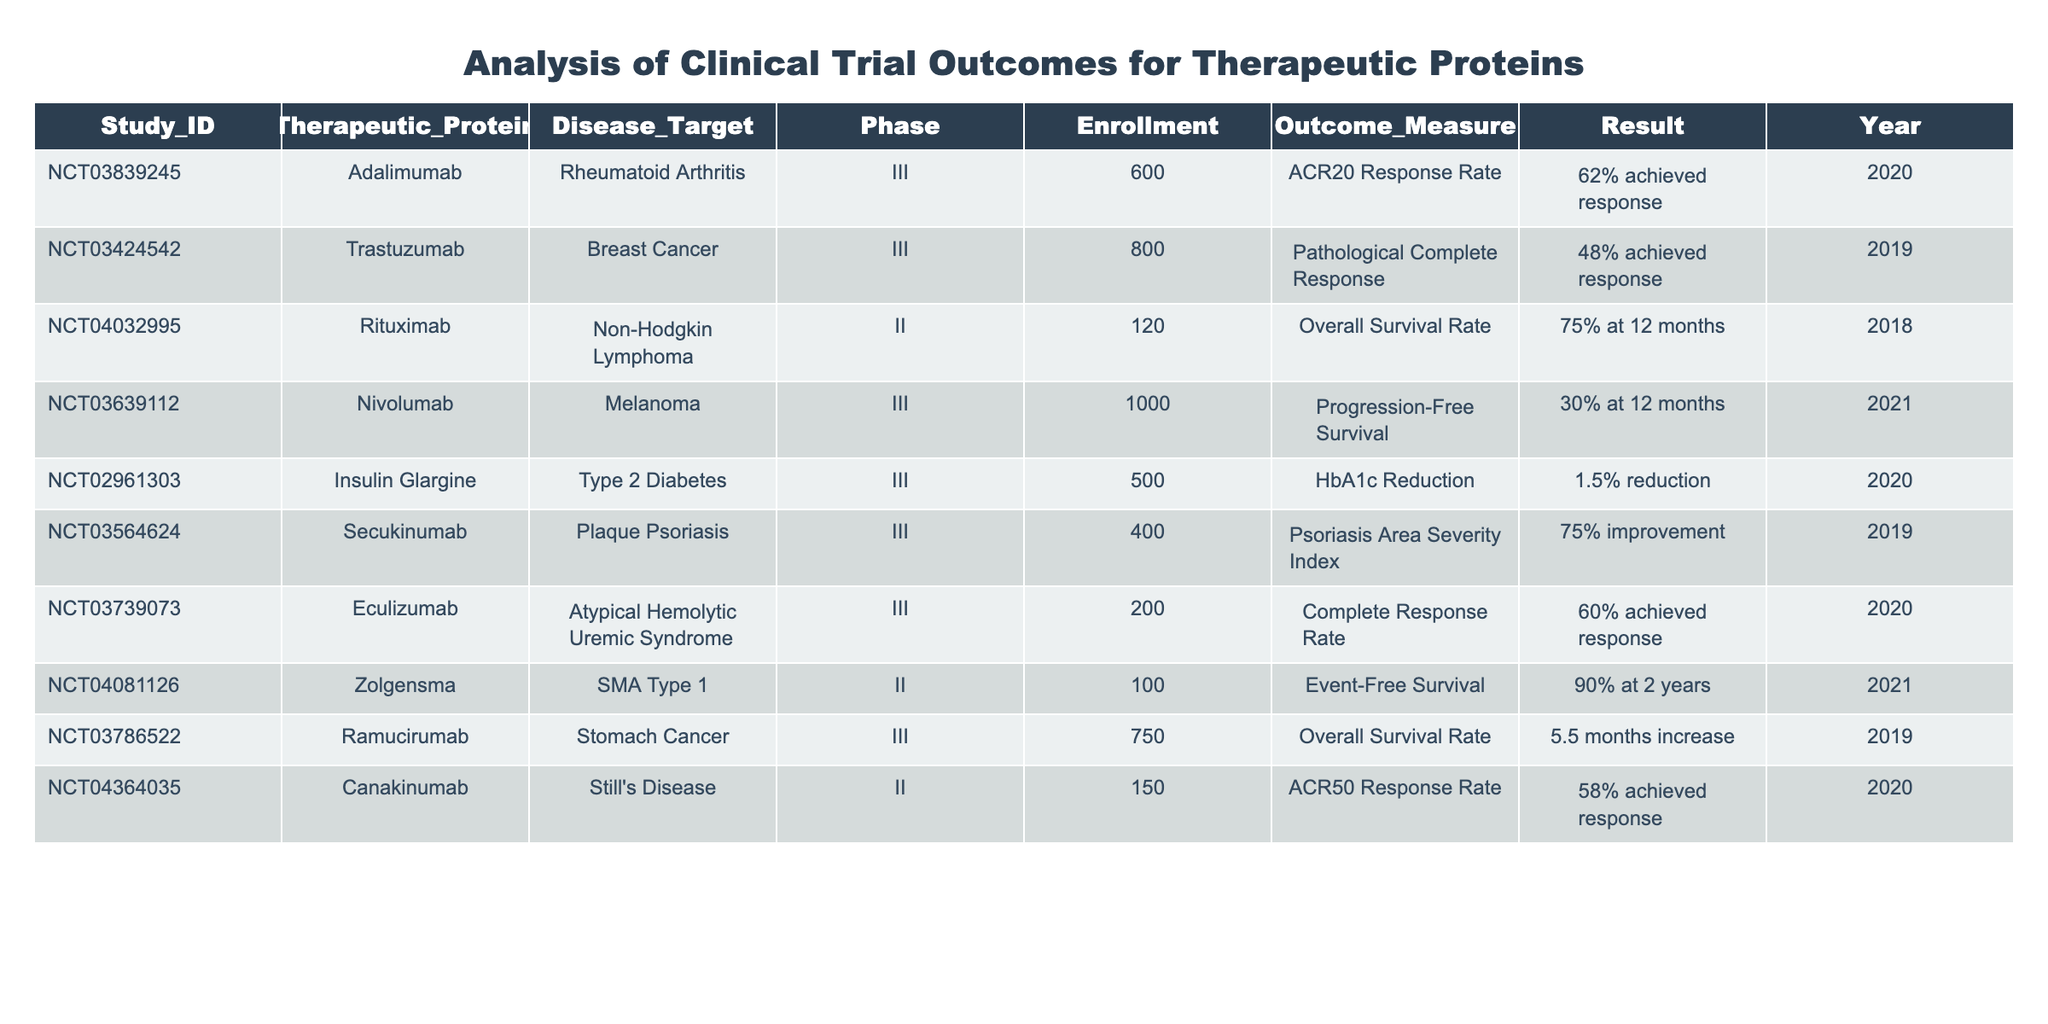What is the enrollment for the study evaluating Zolgensma? The table shows that the enrollment for the study identified by study ID NCT04081126, which evaluates Zolgensma for SMA Type 1, is 100.
Answer: 100 What percentage of participants achieved the ACR20 response rate with Adalimumab? The table indicates that for the study NCT03839245 examining Adalimumab for rheumatoid arthritis, 62% of participants achieved the ACR20 response rate.
Answer: 62% Which therapeutic protein targeting breast cancer had the lowest achievement rate for its outcome measure? From the table, Trastuzumab was evaluated for breast cancer with a pathological complete response where only 48% of participants achieved the response, which is lower than the other therapeutic proteins listed for their respective diseases.
Answer: Trastuzumab Is the progress-free survival rate for Nivolumab at 12 months higher than the overall survival rate for Ramucirumab? The table shows that Nivolumab has a progression-free survival rate of 30% at 12 months, while Ramucirumab has an overall survival rate increase of 5.5 months which does not directly express a percentage to compare. Therefore, the answer is unclear because they are measured in different ways.
Answer: No What is the average reduction in HbA1c across therapeutic proteins targeting diabetes? There is only one entry for diabetes in the table, which is Insulin Glargine with a 1.5% reduction in HbA1c. Hence, the average reduction is actually that single value because there are no other data points to consider for a calculation.
Answer: 1.5% Did more than half of the participants respond to treatment with Secukinumab for plaque psoriasis? The table indicates that 75% of participants improved according to the psoriasis area severity index. Since 75% is more than half, the answer is yes.
Answer: Yes What is the difference in enrollment between studies of Ramucirumab and Canakinumab? Ramucirumab has an enrollment of 750 participants while Canakinumab has 150. The difference can be calculated as 750 - 150 = 600.
Answer: 600 Which therapeutic protein demonstrates the highest event-free survival rate at 2 years? According to the table, Zolgensma shows an event-free survival rate of 90% at 2 years, which is the highest value listed compared to the other therapeutic proteins' outcome measures.
Answer: Zolgensma 